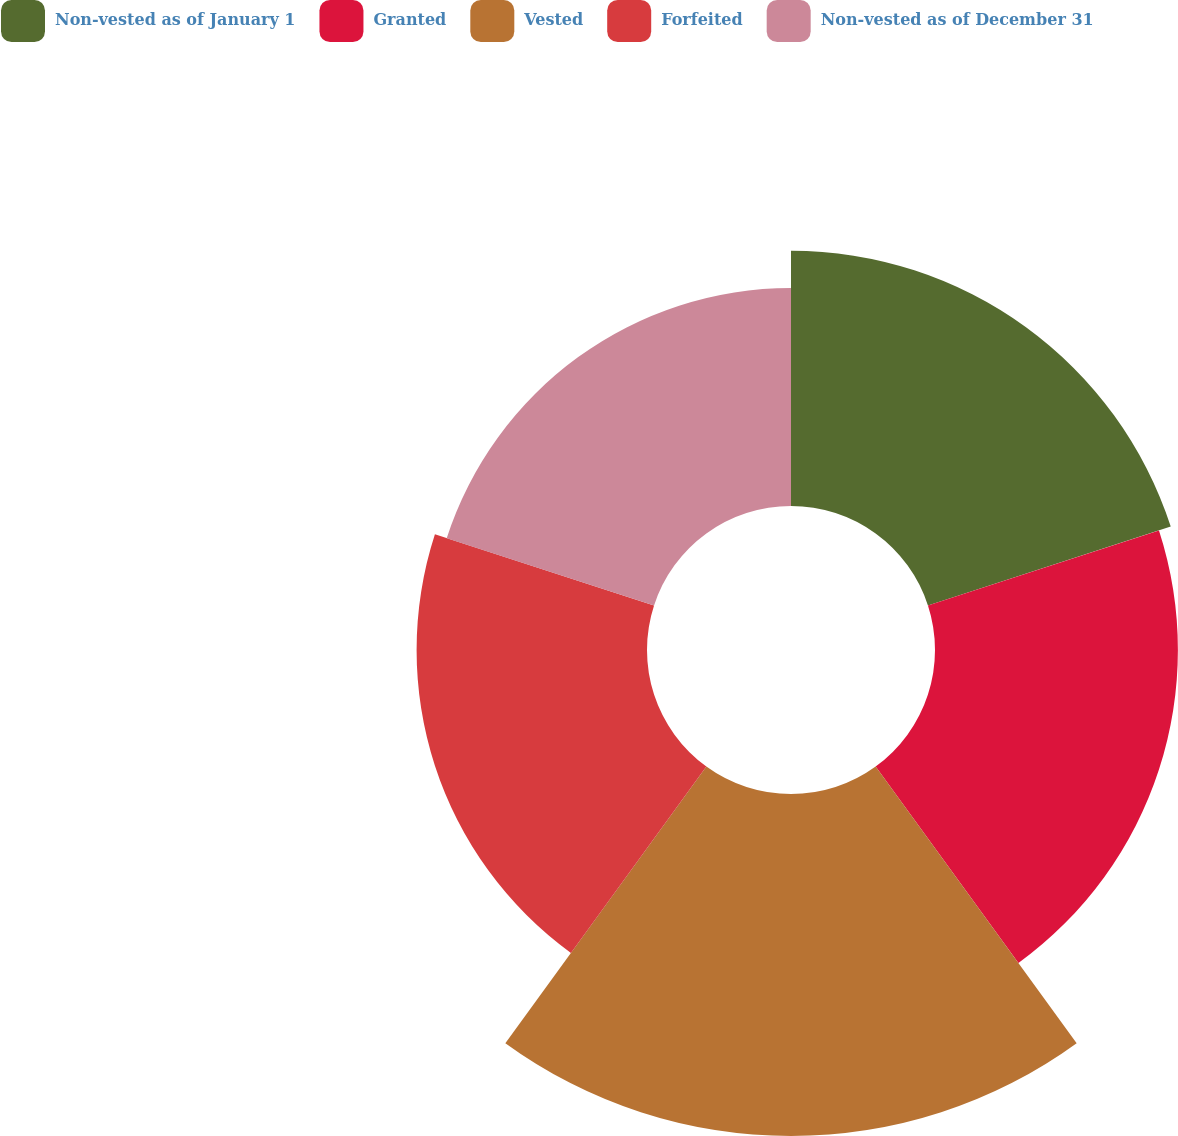<chart> <loc_0><loc_0><loc_500><loc_500><pie_chart><fcel>Non-vested as of January 1<fcel>Granted<fcel>Vested<fcel>Forfeited<fcel>Non-vested as of December 31<nl><fcel>19.81%<fcel>18.85%<fcel>26.54%<fcel>17.88%<fcel>16.92%<nl></chart> 